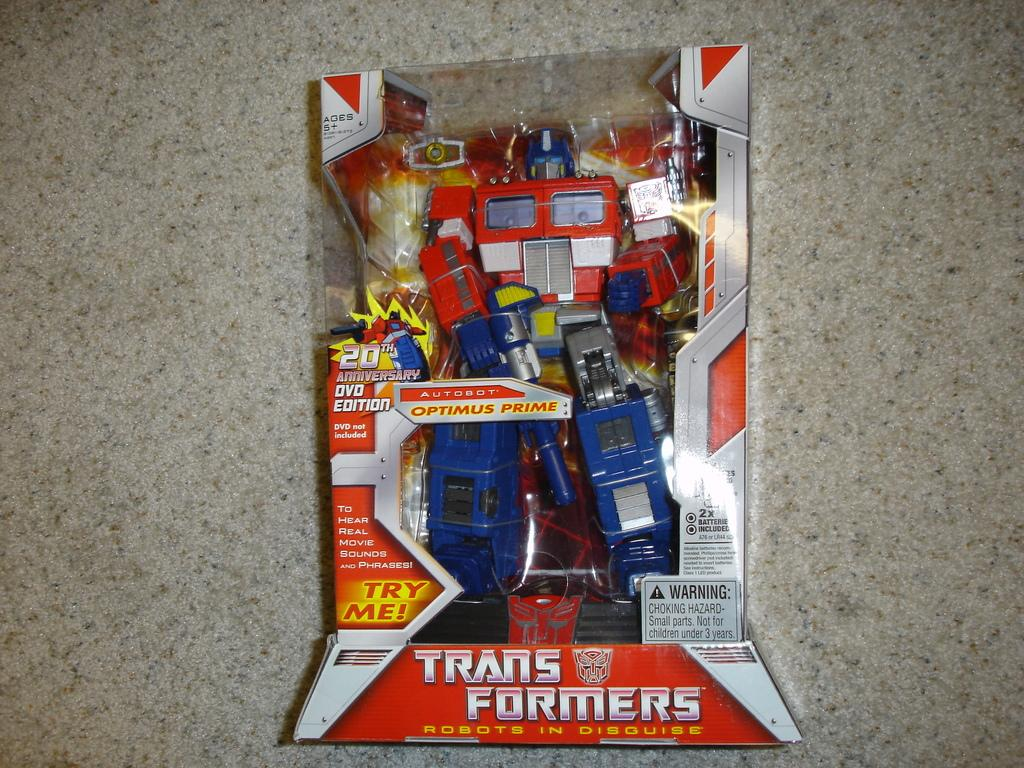<image>
Describe the image concisely. A Transformers box contains Optimus Prime and says try me on it. 